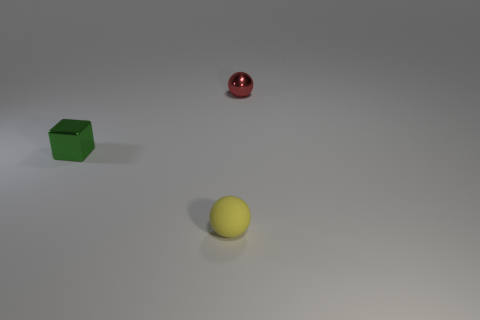Subtract all yellow balls. How many balls are left? 1 Subtract all balls. How many objects are left? 1 Add 3 yellow spheres. How many objects exist? 6 Subtract 1 cubes. How many cubes are left? 0 Add 2 metallic objects. How many metallic objects exist? 4 Subtract 0 purple cylinders. How many objects are left? 3 Subtract all cyan spheres. Subtract all red blocks. How many spheres are left? 2 Subtract all purple cubes. How many green spheres are left? 0 Subtract all tiny green shiny cubes. Subtract all shiny objects. How many objects are left? 0 Add 2 small green cubes. How many small green cubes are left? 3 